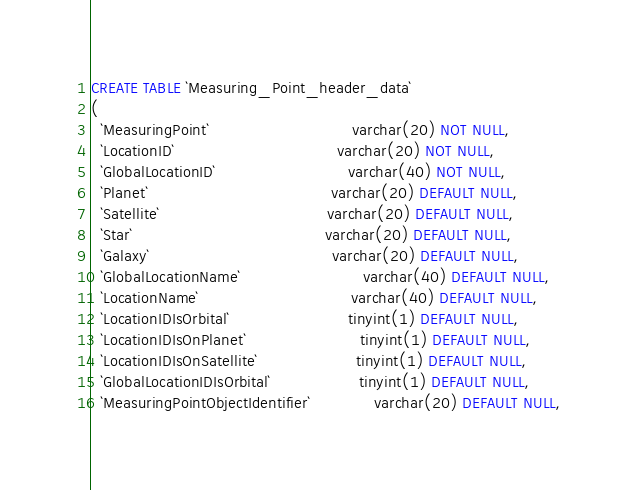Convert code to text. <code><loc_0><loc_0><loc_500><loc_500><_SQL_>CREATE TABLE `Measuring_Point_header_data`
(
  `MeasuringPoint`                             varchar(20) NOT NULL,
  `LocationID`                                 varchar(20) NOT NULL,
  `GlobalLocationID`                           varchar(40) NOT NULL,
  `Planet`                                     varchar(20) DEFAULT NULL,
  `Satellite`                                  varchar(20) DEFAULT NULL,
  `Star`                                       varchar(20) DEFAULT NULL,
  `Galaxy`                                     varchar(20) DEFAULT NULL,
  `GlobalLocationName`                         varchar(40) DEFAULT NULL,
  `LocationName`                               varchar(40) DEFAULT NULL,
  `LocationIDIsOrbital`                        tinyint(1) DEFAULT NULL,
  `LocationIDIsOnPlanet`                       tinyint(1) DEFAULT NULL,
  `LocationIDIsOnSatellite`                    tinyint(1) DEFAULT NULL,
  `GlobalLocationIDIsOrbital`                  tinyint(1) DEFAULT NULL,
  `MeasuringPointObjectIdentifier`             varchar(20) DEFAULT NULL,</code> 